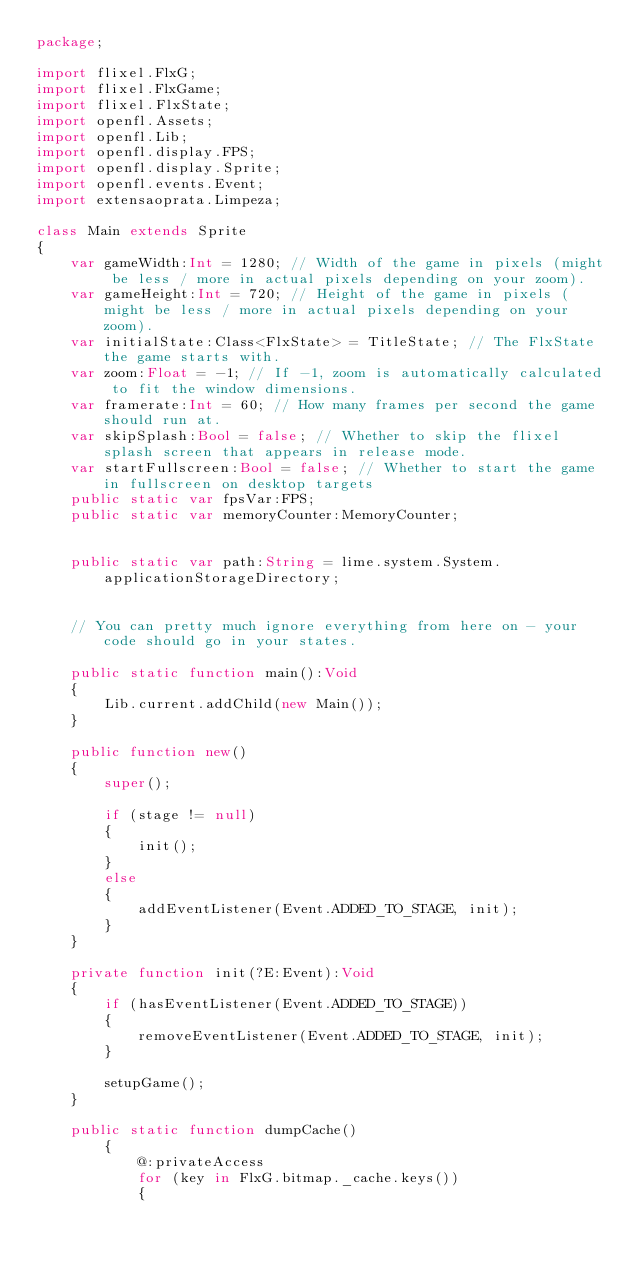Convert code to text. <code><loc_0><loc_0><loc_500><loc_500><_Haxe_>package;

import flixel.FlxG;
import flixel.FlxGame;
import flixel.FlxState;
import openfl.Assets;
import openfl.Lib;
import openfl.display.FPS;
import openfl.display.Sprite;
import openfl.events.Event;
import extensaoprata.Limpeza;

class Main extends Sprite
{
	var gameWidth:Int = 1280; // Width of the game in pixels (might be less / more in actual pixels depending on your zoom).
	var gameHeight:Int = 720; // Height of the game in pixels (might be less / more in actual pixels depending on your zoom).
	var initialState:Class<FlxState> = TitleState; // The FlxState the game starts with.
	var zoom:Float = -1; // If -1, zoom is automatically calculated to fit the window dimensions.
	var framerate:Int = 60; // How many frames per second the game should run at.
	var skipSplash:Bool = false; // Whether to skip the flixel splash screen that appears in release mode.
	var startFullscreen:Bool = false; // Whether to start the game in fullscreen on desktop targets
	public static var fpsVar:FPS;
	public static var memoryCounter:MemoryCounter;


	public static var path:String = lime.system.System.applicationStorageDirectory;


	// You can pretty much ignore everything from here on - your code should go in your states.

	public static function main():Void
	{
		Lib.current.addChild(new Main());
	}

	public function new()
	{
		super();

		if (stage != null)
		{
			init();
		}
		else
		{
			addEventListener(Event.ADDED_TO_STAGE, init);
		}
	}

	private function init(?E:Event):Void
	{
		if (hasEventListener(Event.ADDED_TO_STAGE))
		{
			removeEventListener(Event.ADDED_TO_STAGE, init);
		}

		setupGame();
	}

	public static function dumpCache()
		{
			@:privateAccess
			for (key in FlxG.bitmap._cache.keys())
			{</code> 